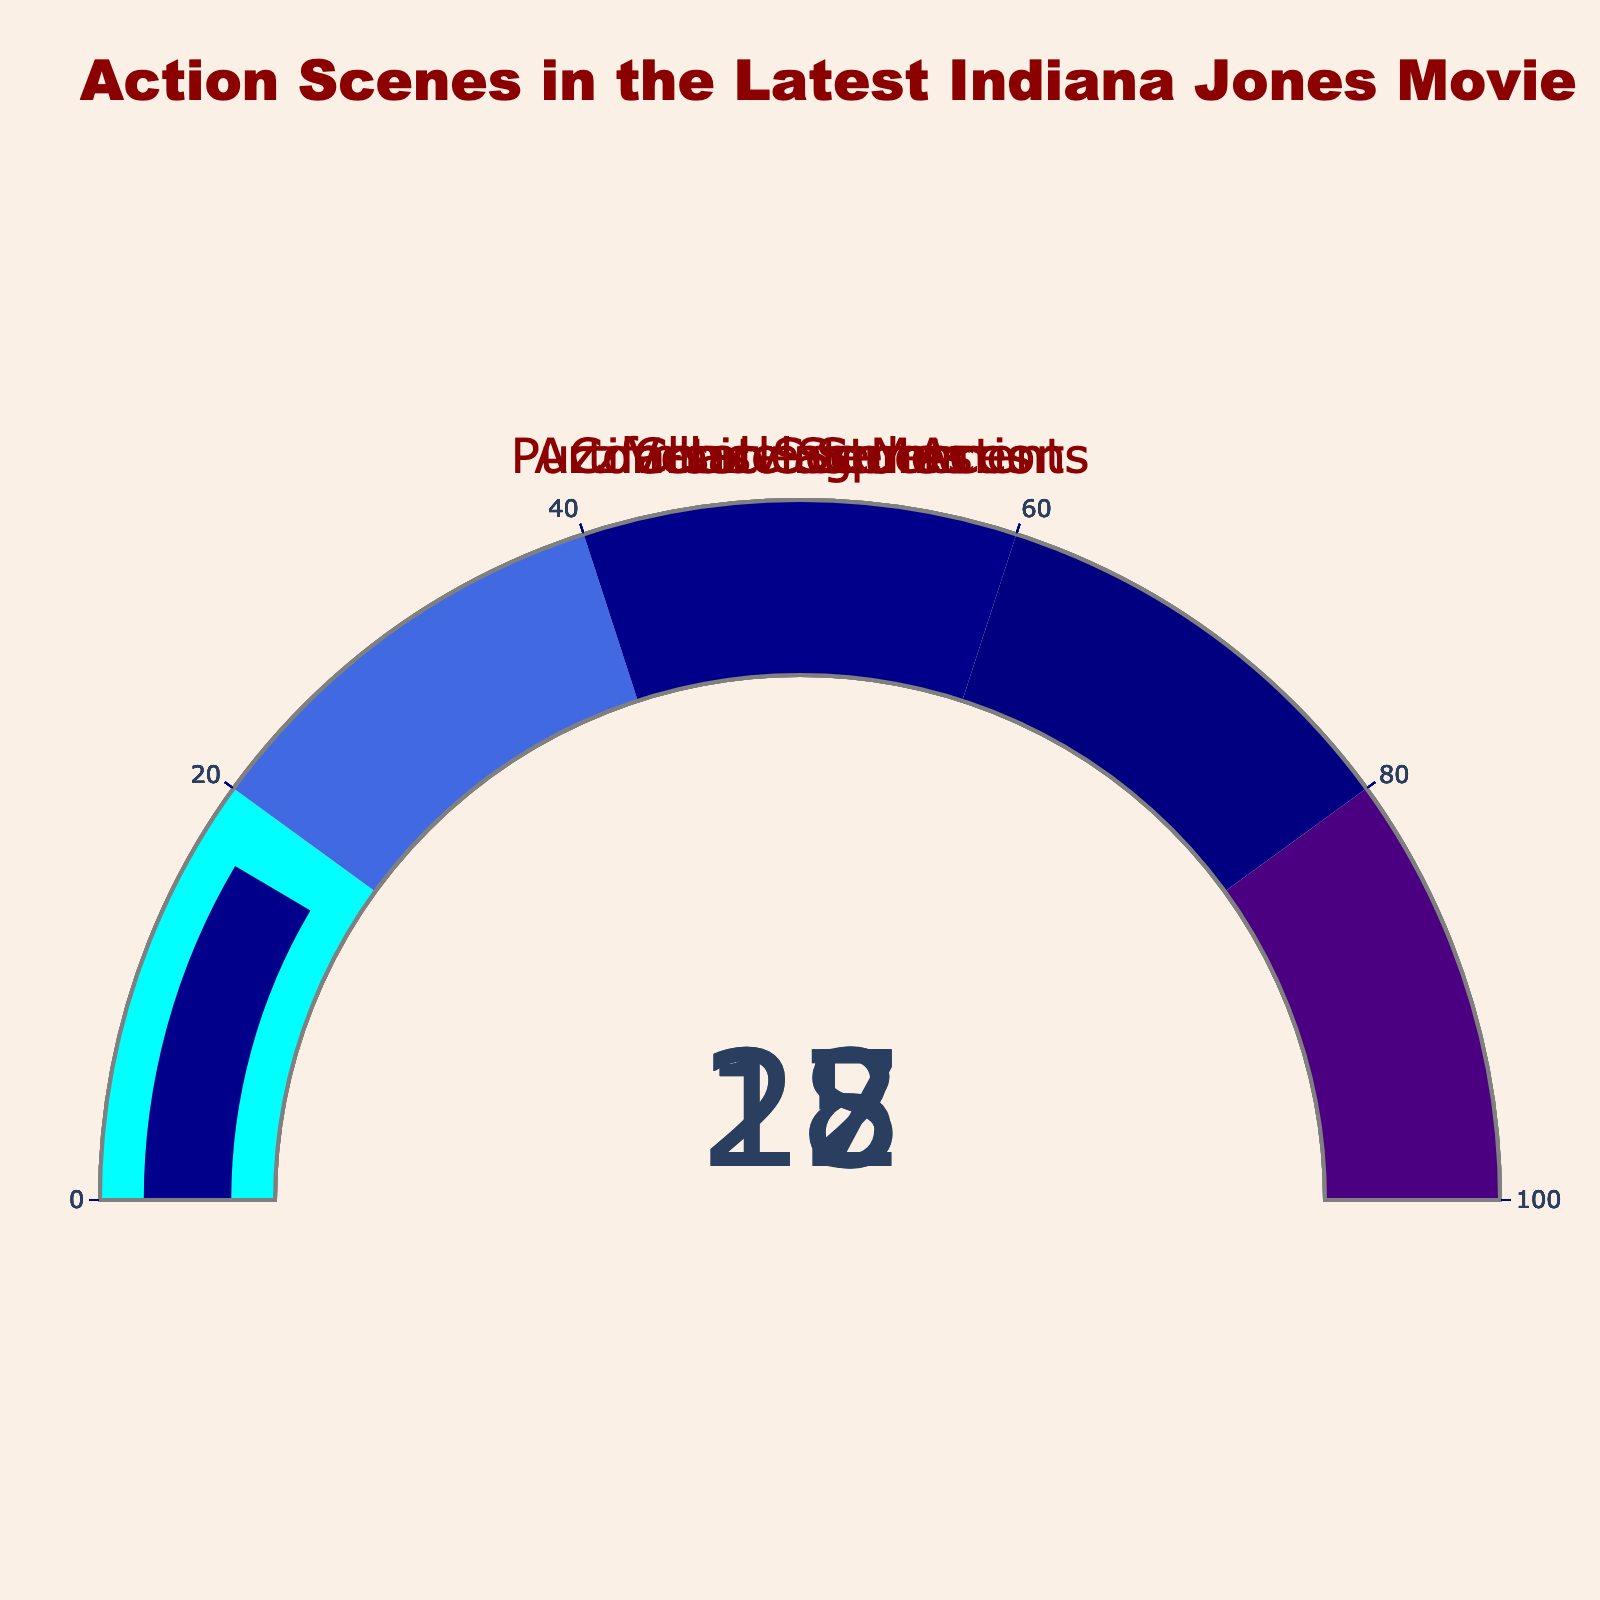What is the highest percentage among all action types? Among all the gauges representing different action types, Chase Scenes has the highest percentage of 28% which is the most prominent number on the gauge chart.
Answer: 28% What is the title of the gauge chart? The title is centered at the top of the chart and reads "Action Scenes in the Latest Indiana Jones Movie".
Answer: Action Scenes in the Latest Indiana Jones Movie Which action type has the lowest percentage? By comparing the values displayed on the gauges, Puzzle-solving Moments has the lowest percentage at 15%.
Answer: Puzzle-solving Moments What is the sum of the percentages for Combat Sequences and Vehicle Stunts? Add the percentages for Combat Sequences (22%) and Vehicle Stunts (18%), which gives 22 + 18 = 40.
Answer: 40 How many action types are represented in the gauge chart? By counting the number of gauges, we can see there are five action types shown.
Answer: 5 Which action type has a higher percentage: Artifact-related Action or Combat Sequences? Compare the percentages shown on the gauges, where Artifact-related Action is 17% and Combat Sequences is 22%. Combat Sequences is higher.
Answer: Combat Sequences What is the average percentage of the five action types? Sum the percentages of all five action types and divide by the number of types: (28 + 22 + 15 + 18 + 17) / 5 = 20.
Answer: 20 What is the color of the step range for the 50-60% interval? The color for the 50-60% interval step on the gauge chart is dark blue.
Answer: dark blue Which action type has an equal percentage to the color cyan range? The cyan color range is for 0-20%, and Puzzle-solving Moments, at 15%, falls within this range.
Answer: Puzzle-solving Moments Are any action types’ percentages greater than 25%? By examining the percentages, only Chase Scenes at 28% is greater than 25%.
Answer: Yes 